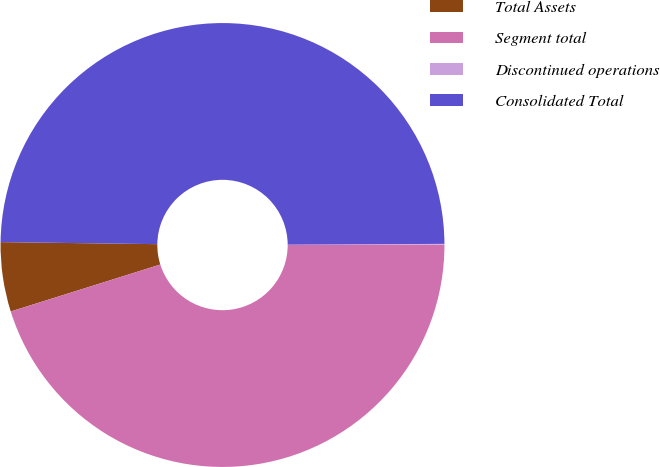Convert chart to OTSL. <chart><loc_0><loc_0><loc_500><loc_500><pie_chart><fcel>Total Assets<fcel>Segment total<fcel>Discontinued operations<fcel>Consolidated Total<nl><fcel>5.05%<fcel>45.19%<fcel>0.05%<fcel>49.71%<nl></chart> 